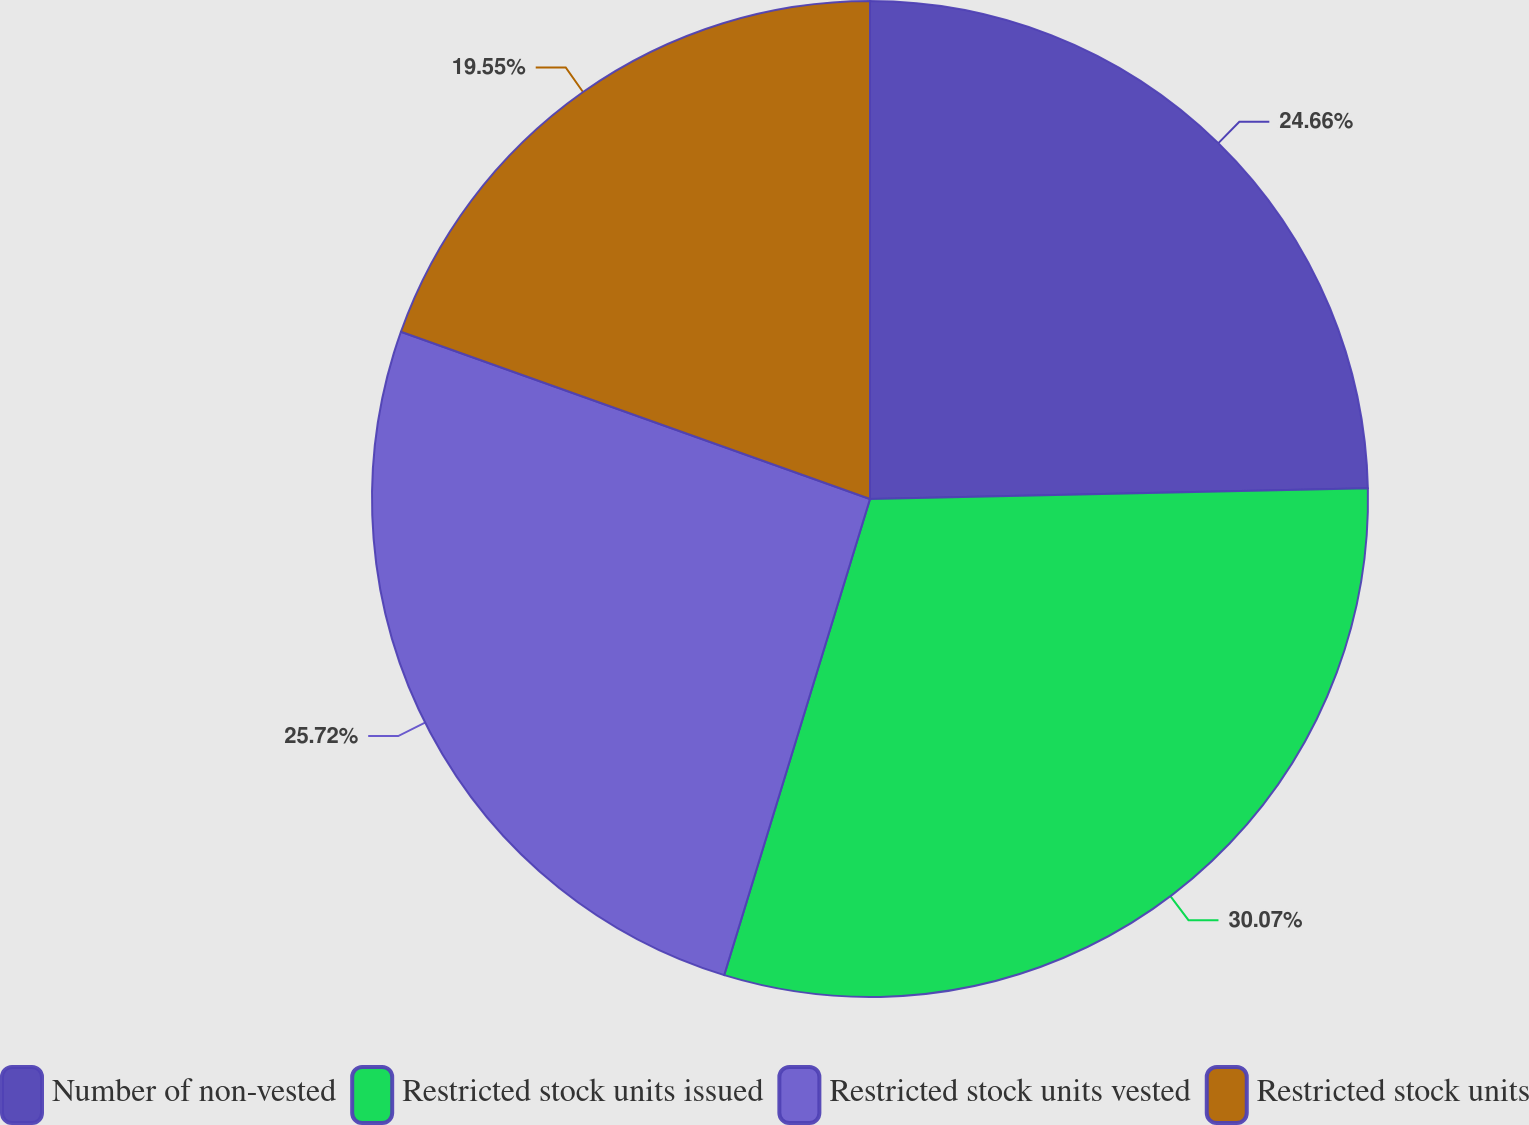<chart> <loc_0><loc_0><loc_500><loc_500><pie_chart><fcel>Number of non-vested<fcel>Restricted stock units issued<fcel>Restricted stock units vested<fcel>Restricted stock units<nl><fcel>24.66%<fcel>30.07%<fcel>25.72%<fcel>19.55%<nl></chart> 